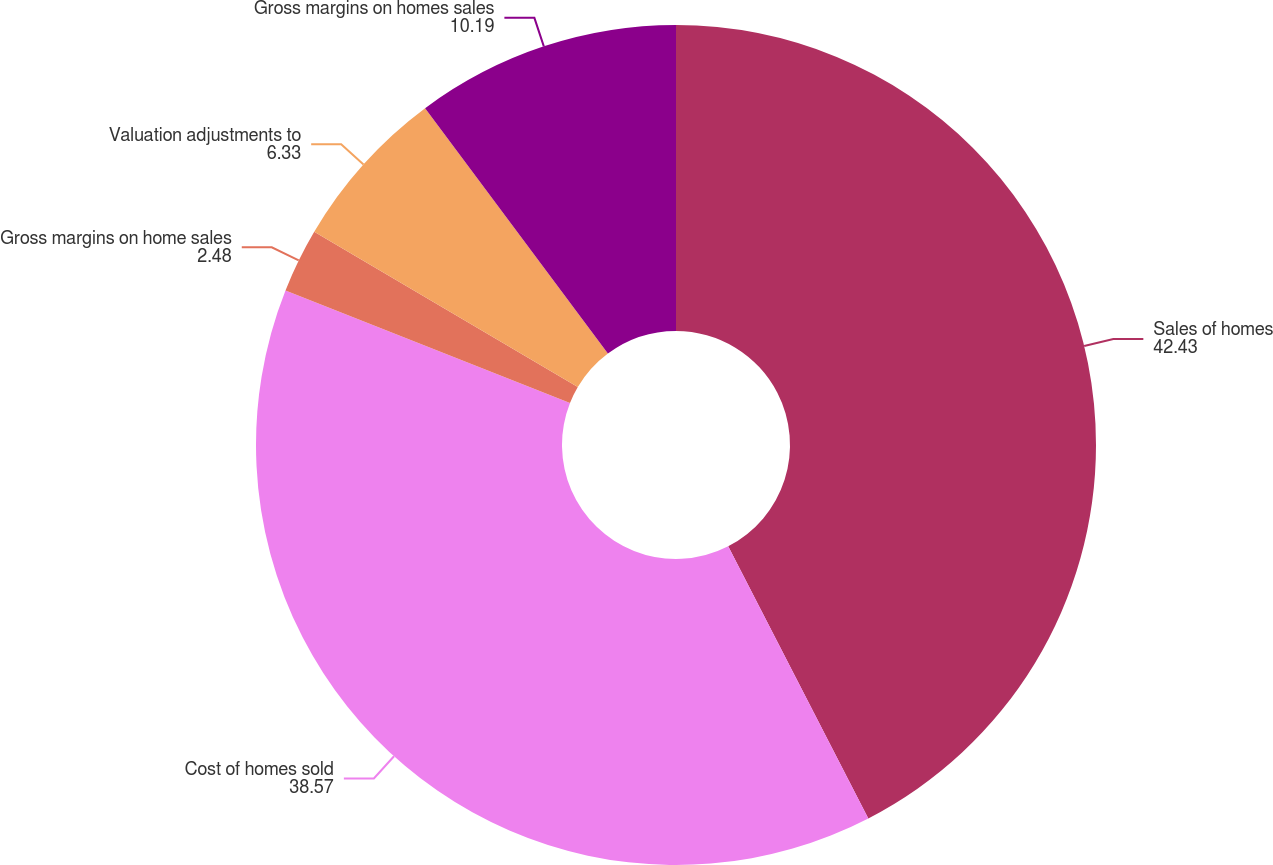<chart> <loc_0><loc_0><loc_500><loc_500><pie_chart><fcel>Sales of homes<fcel>Cost of homes sold<fcel>Gross margins on home sales<fcel>Valuation adjustments to<fcel>Gross margins on homes sales<nl><fcel>42.43%<fcel>38.57%<fcel>2.48%<fcel>6.33%<fcel>10.19%<nl></chart> 